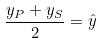Convert formula to latex. <formula><loc_0><loc_0><loc_500><loc_500>\frac { y _ { P } + y _ { S } } { 2 } = \hat { y }</formula> 